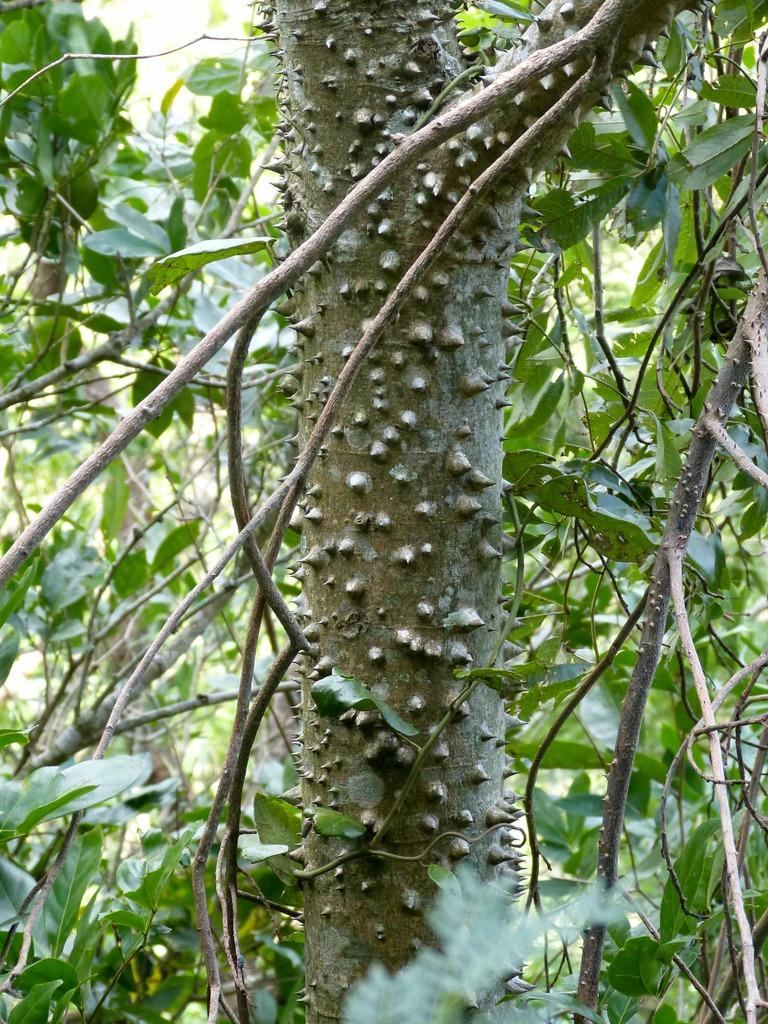What is the main subject in the center of the image? There is a tree trunk in the center of the image. What else can be seen in the image besides the tree trunk? There are leaves in the image. What type of unit is being measured with the salt in the image? There is no unit or salt present in the image; it only features a tree trunk and leaves. 